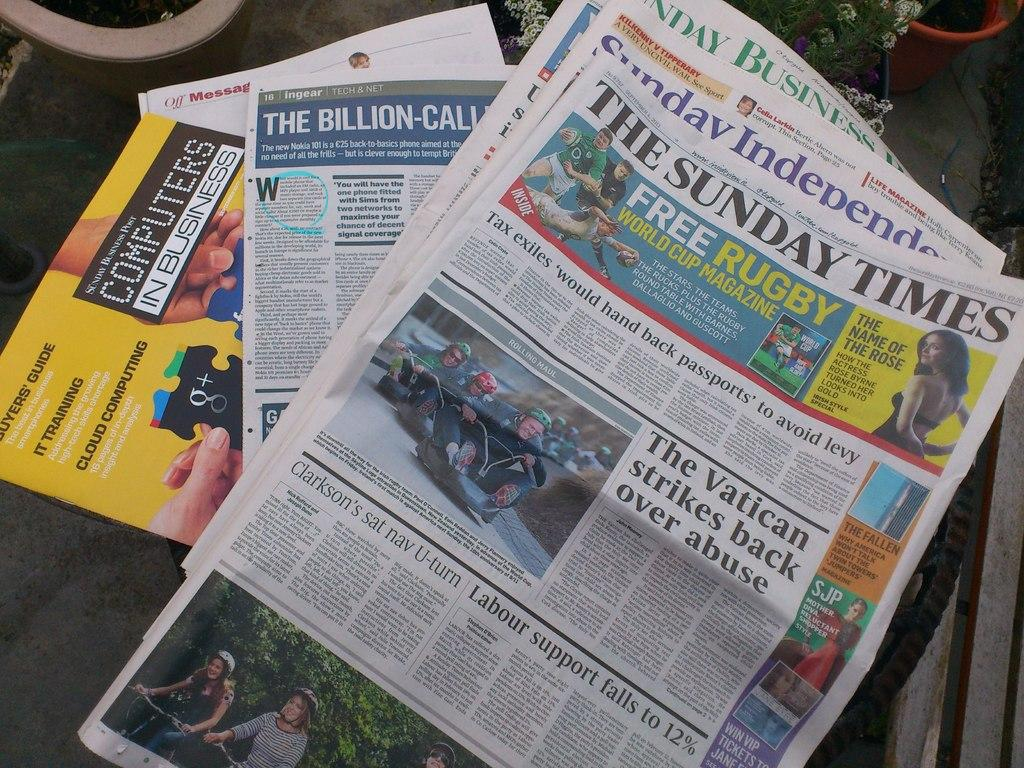<image>
Present a compact description of the photo's key features. A newspaper The Sunday Times with an artical The Vatican strikes back over abuse. 